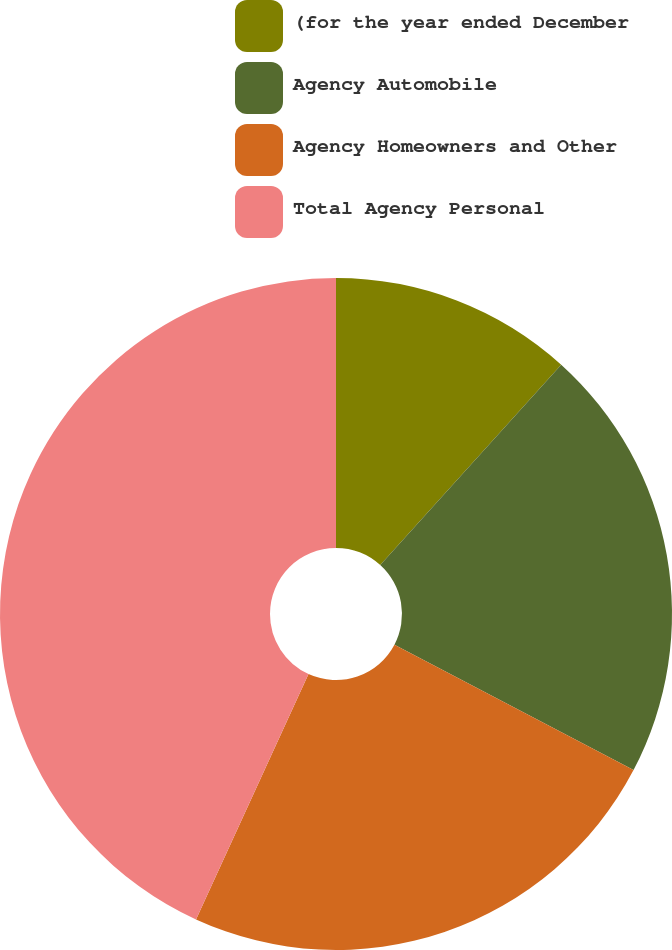<chart> <loc_0><loc_0><loc_500><loc_500><pie_chart><fcel>(for the year ended December<fcel>Agency Automobile<fcel>Agency Homeowners and Other<fcel>Total Agency Personal<nl><fcel>11.69%<fcel>21.0%<fcel>24.15%<fcel>43.16%<nl></chart> 